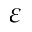Convert formula to latex. <formula><loc_0><loc_0><loc_500><loc_500>\varepsilon</formula> 